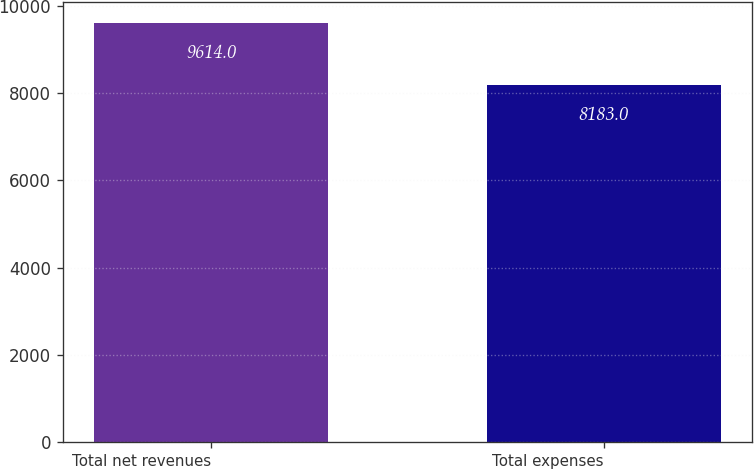<chart> <loc_0><loc_0><loc_500><loc_500><bar_chart><fcel>Total net revenues<fcel>Total expenses<nl><fcel>9614<fcel>8183<nl></chart> 